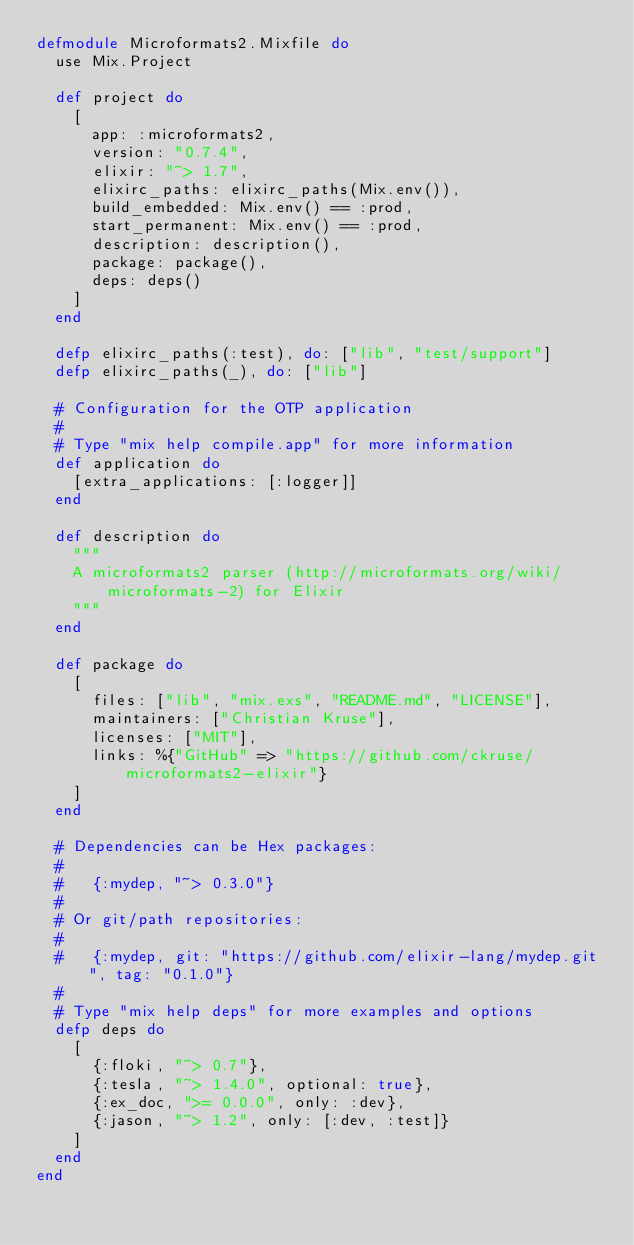<code> <loc_0><loc_0><loc_500><loc_500><_Elixir_>defmodule Microformats2.Mixfile do
  use Mix.Project

  def project do
    [
      app: :microformats2,
      version: "0.7.4",
      elixir: "~> 1.7",
      elixirc_paths: elixirc_paths(Mix.env()),
      build_embedded: Mix.env() == :prod,
      start_permanent: Mix.env() == :prod,
      description: description(),
      package: package(),
      deps: deps()
    ]
  end

  defp elixirc_paths(:test), do: ["lib", "test/support"]
  defp elixirc_paths(_), do: ["lib"]

  # Configuration for the OTP application
  #
  # Type "mix help compile.app" for more information
  def application do
    [extra_applications: [:logger]]
  end

  def description do
    """
    A microformats2 parser (http://microformats.org/wiki/microformats-2) for Elixir
    """
  end

  def package do
    [
      files: ["lib", "mix.exs", "README.md", "LICENSE"],
      maintainers: ["Christian Kruse"],
      licenses: ["MIT"],
      links: %{"GitHub" => "https://github.com/ckruse/microformats2-elixir"}
    ]
  end

  # Dependencies can be Hex packages:
  #
  #   {:mydep, "~> 0.3.0"}
  #
  # Or git/path repositories:
  #
  #   {:mydep, git: "https://github.com/elixir-lang/mydep.git", tag: "0.1.0"}
  #
  # Type "mix help deps" for more examples and options
  defp deps do
    [
      {:floki, "~> 0.7"},
      {:tesla, "~> 1.4.0", optional: true},
      {:ex_doc, ">= 0.0.0", only: :dev},
      {:jason, "~> 1.2", only: [:dev, :test]}
    ]
  end
end
</code> 